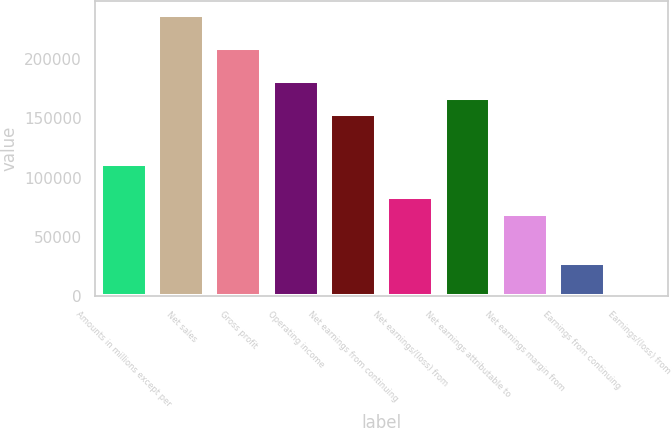Convert chart to OTSL. <chart><loc_0><loc_0><loc_500><loc_500><bar_chart><fcel>Amounts in millions except per<fcel>Net sales<fcel>Gross profit<fcel>Operating income<fcel>Net earnings from continuing<fcel>Net earnings/(loss) from<fcel>Net earnings attributable to<fcel>Net earnings margin from<fcel>Earnings from continuing<fcel>Earnings/(loss) from<nl><fcel>111410<fcel>236747<fcel>208894<fcel>181042<fcel>153189<fcel>83557.9<fcel>167116<fcel>69631.7<fcel>27852.9<fcel>0.39<nl></chart> 